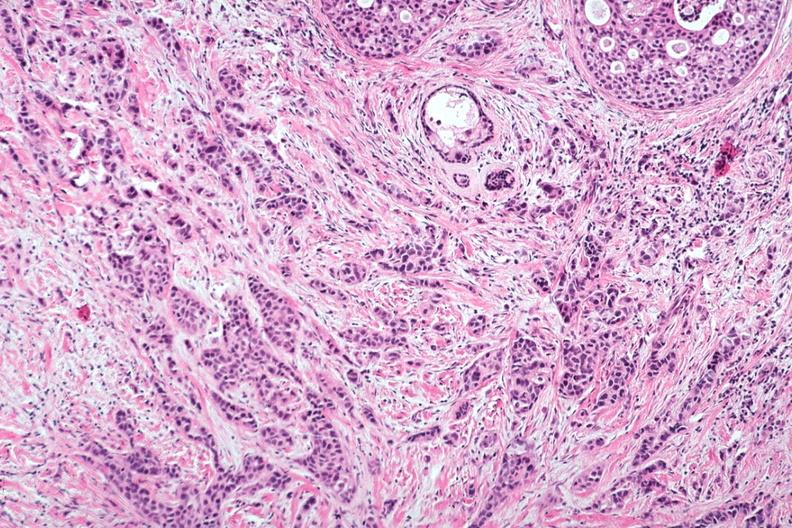what does this image show?
Answer the question using a single word or phrase. Excellent invasive tumor with marked desmoplastic reaction 